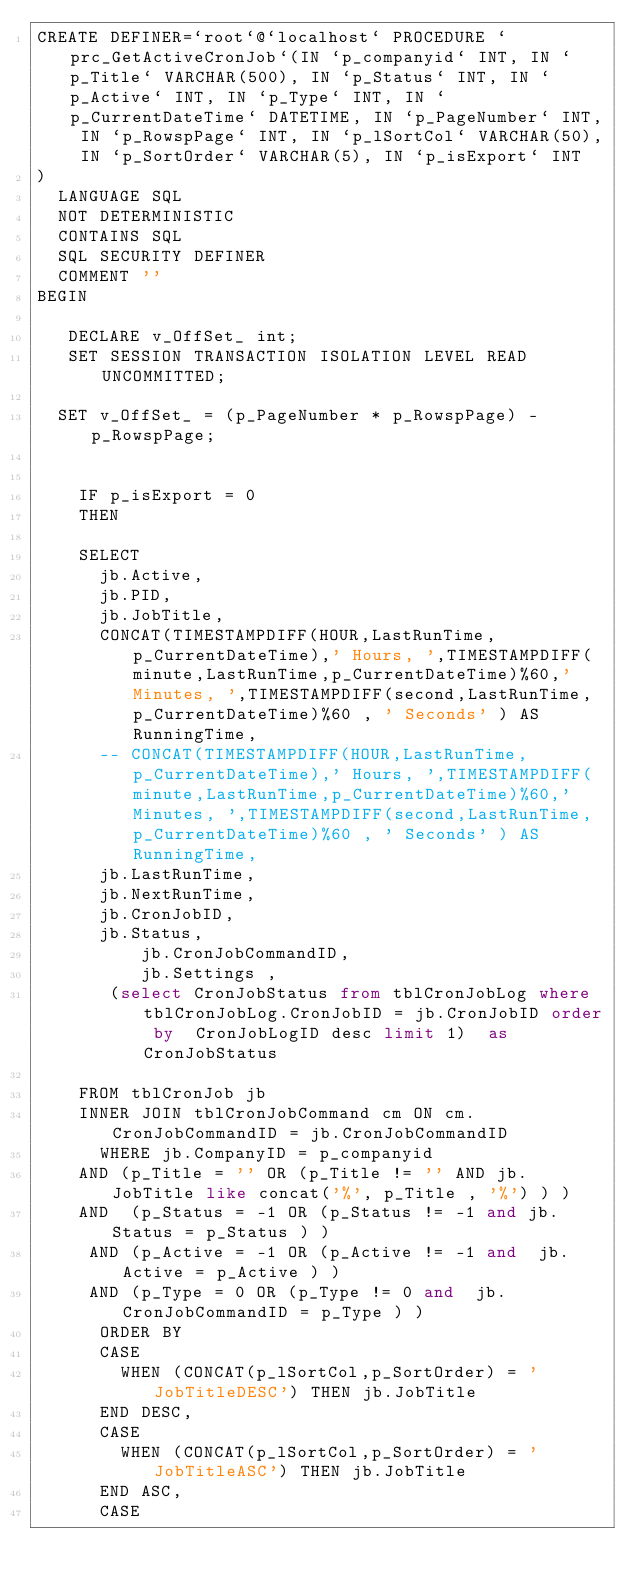<code> <loc_0><loc_0><loc_500><loc_500><_SQL_>CREATE DEFINER=`root`@`localhost` PROCEDURE `prc_GetActiveCronJob`(IN `p_companyid` INT, IN `p_Title` VARCHAR(500), IN `p_Status` INT, IN `p_Active` INT, IN `p_Type` INT, IN `p_CurrentDateTime` DATETIME, IN `p_PageNumber` INT, IN `p_RowspPage` INT, IN `p_lSortCol` VARCHAR(50), IN `p_SortOrder` VARCHAR(5), IN `p_isExport` INT
)
	LANGUAGE SQL
	NOT DETERMINISTIC
	CONTAINS SQL
	SQL SECURITY DEFINER
	COMMENT ''
BEGIN

   DECLARE v_OffSet_ int;
   SET SESSION TRANSACTION ISOLATION LEVEL READ UNCOMMITTED;

	SET v_OffSet_ = (p_PageNumber * p_RowspPage) - p_RowspPage;


    IF p_isExport = 0
    THEN

		SELECT
			jb.Active,
			jb.PID,
			jb.JobTitle,
			CONCAT(TIMESTAMPDIFF(HOUR,LastRunTime,p_CurrentDateTime),' Hours, ',TIMESTAMPDIFF(minute,LastRunTime,p_CurrentDateTime)%60,' Minutes, ',TIMESTAMPDIFF(second,LastRunTime,p_CurrentDateTime)%60 , ' Seconds' ) AS RunningTime,
			-- CONCAT(TIMESTAMPDIFF(HOUR,LastRunTime,p_CurrentDateTime),' Hours, ',TIMESTAMPDIFF(minute,LastRunTime,p_CurrentDateTime)%60,' Minutes, ',TIMESTAMPDIFF(second,LastRunTime,p_CurrentDateTime)%60 , ' Seconds' ) AS RunningTime,
 			jb.LastRunTime,
			jb.NextRunTime,
			jb.CronJobID,
			jb.Status,
          jb.CronJobCommandID,
          jb.Settings	,
 		   (select CronJobStatus from tblCronJobLog where tblCronJobLog.CronJobID = jb.CronJobID order by  CronJobLogID desc limit 1)  as  CronJobStatus

		FROM tblCronJob jb
		INNER JOIN tblCronJobCommand cm ON cm.CronJobCommandID = jb.CronJobCommandID
      WHERE jb.CompanyID = p_companyid
		AND (p_Title = '' OR (p_Title != '' AND jb.JobTitle like concat('%', p_Title , '%') ) )
		AND  (p_Status = -1 OR (p_Status != -1 and jb.Status = p_Status ) )
		 AND (p_Active = -1 OR (p_Active != -1 and  jb.Active = p_Active ) )
		 AND (p_Type = 0 OR (p_Type != 0 and  jb.CronJobCommandID = p_Type ) )
      ORDER BY
			CASE
			  WHEN (CONCAT(p_lSortCol,p_SortOrder) = 'JobTitleDESC') THEN jb.JobTitle
			END DESC,
			CASE
			  WHEN (CONCAT(p_lSortCol,p_SortOrder) = 'JobTitleASC') THEN jb.JobTitle
			END ASC,
			CASE</code> 